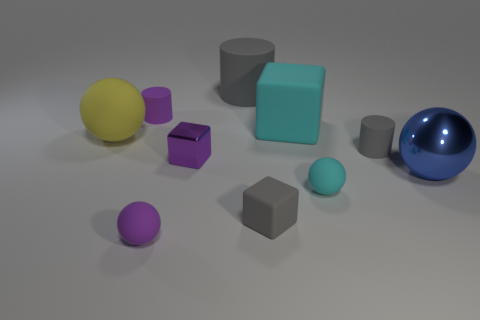Subtract all big yellow balls. How many balls are left? 3 Subtract all blocks. How many objects are left? 7 Subtract all blue cubes. How many gray cylinders are left? 2 Subtract all gray cylinders. How many cylinders are left? 1 Subtract 2 cylinders. How many cylinders are left? 1 Subtract 1 yellow balls. How many objects are left? 9 Subtract all red cubes. Subtract all yellow cylinders. How many cubes are left? 3 Subtract all tiny things. Subtract all spheres. How many objects are left? 0 Add 9 large yellow objects. How many large yellow objects are left? 10 Add 2 purple matte cylinders. How many purple matte cylinders exist? 3 